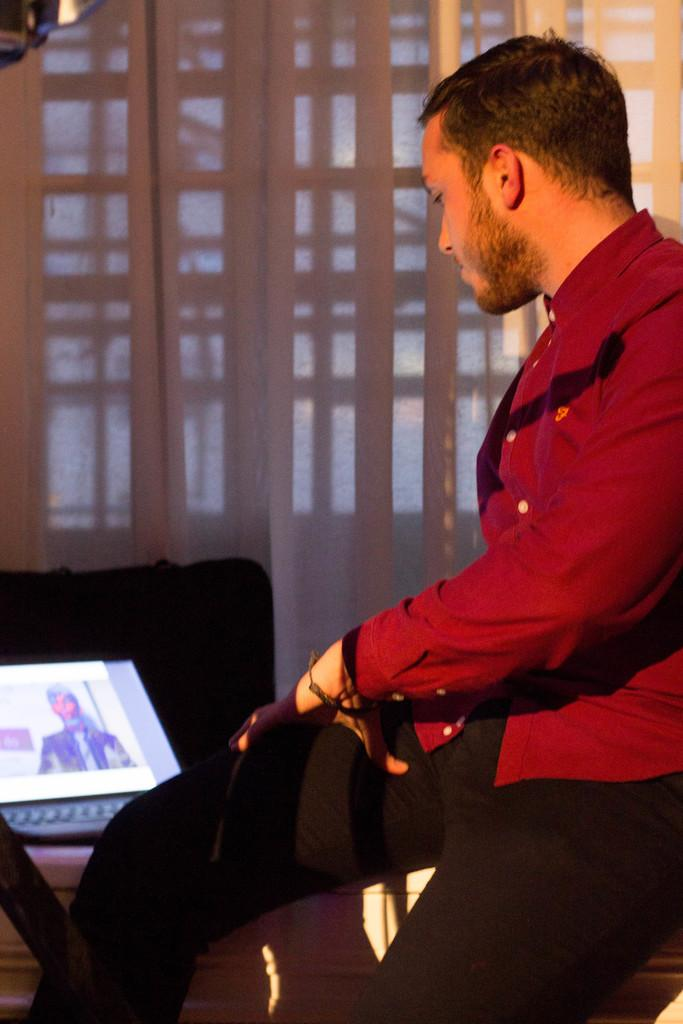What is the man in the image doing? The man is sitting in the image. What object is in front of the man? The man is in front of a laptop. What can be seen in the background of the image? There is a window in the background of the image. Is there any window treatment present in the image? Yes, there is a curtain associated with the window. What type of butter can be seen melting on the desk in the image? There is no butter or desk present in the image. 